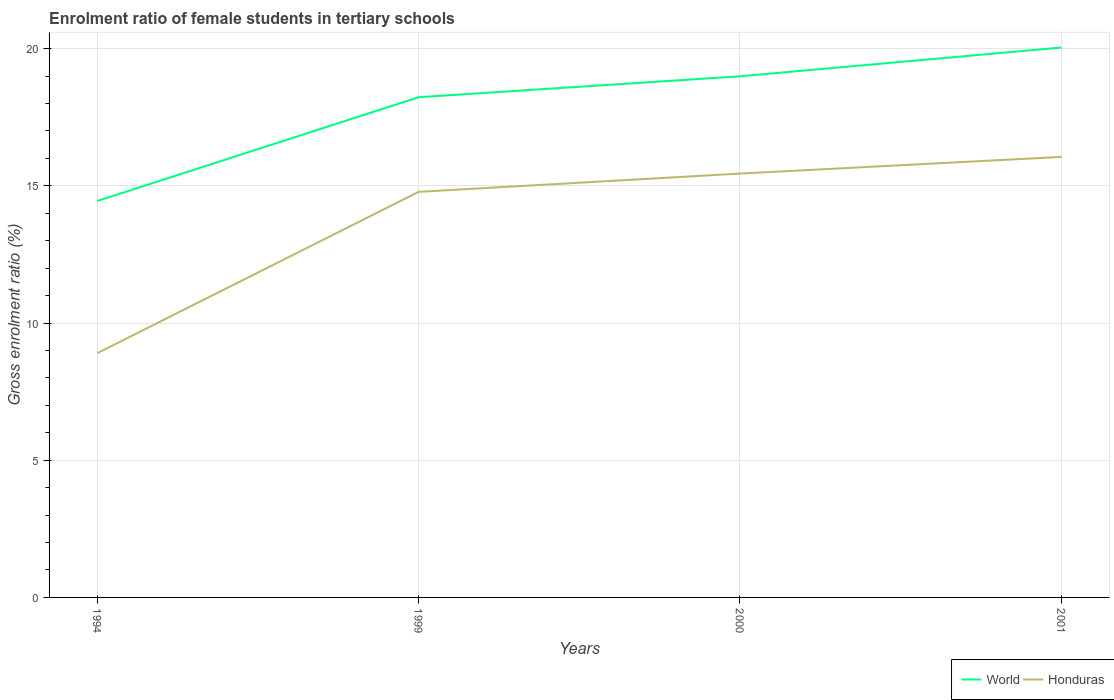How many different coloured lines are there?
Make the answer very short. 2. Does the line corresponding to Honduras intersect with the line corresponding to World?
Give a very brief answer. No. Across all years, what is the maximum enrolment ratio of female students in tertiary schools in Honduras?
Your response must be concise. 8.9. In which year was the enrolment ratio of female students in tertiary schools in World maximum?
Make the answer very short. 1994. What is the total enrolment ratio of female students in tertiary schools in World in the graph?
Give a very brief answer. -5.59. What is the difference between the highest and the second highest enrolment ratio of female students in tertiary schools in World?
Your answer should be very brief. 5.59. What is the difference between the highest and the lowest enrolment ratio of female students in tertiary schools in Honduras?
Offer a very short reply. 3. Is the enrolment ratio of female students in tertiary schools in World strictly greater than the enrolment ratio of female students in tertiary schools in Honduras over the years?
Make the answer very short. No. What is the difference between two consecutive major ticks on the Y-axis?
Your answer should be compact. 5. Does the graph contain grids?
Keep it short and to the point. Yes. How many legend labels are there?
Your answer should be very brief. 2. What is the title of the graph?
Your response must be concise. Enrolment ratio of female students in tertiary schools. What is the label or title of the X-axis?
Your response must be concise. Years. What is the label or title of the Y-axis?
Keep it short and to the point. Gross enrolment ratio (%). What is the Gross enrolment ratio (%) in World in 1994?
Ensure brevity in your answer.  14.45. What is the Gross enrolment ratio (%) in Honduras in 1994?
Your answer should be compact. 8.9. What is the Gross enrolment ratio (%) in World in 1999?
Offer a terse response. 18.23. What is the Gross enrolment ratio (%) in Honduras in 1999?
Your answer should be compact. 14.78. What is the Gross enrolment ratio (%) of World in 2000?
Your response must be concise. 18.99. What is the Gross enrolment ratio (%) of Honduras in 2000?
Give a very brief answer. 15.45. What is the Gross enrolment ratio (%) of World in 2001?
Your answer should be very brief. 20.04. What is the Gross enrolment ratio (%) of Honduras in 2001?
Keep it short and to the point. 16.06. Across all years, what is the maximum Gross enrolment ratio (%) in World?
Offer a very short reply. 20.04. Across all years, what is the maximum Gross enrolment ratio (%) in Honduras?
Provide a succinct answer. 16.06. Across all years, what is the minimum Gross enrolment ratio (%) in World?
Give a very brief answer. 14.45. Across all years, what is the minimum Gross enrolment ratio (%) in Honduras?
Your answer should be compact. 8.9. What is the total Gross enrolment ratio (%) in World in the graph?
Your answer should be compact. 71.71. What is the total Gross enrolment ratio (%) of Honduras in the graph?
Your answer should be very brief. 55.19. What is the difference between the Gross enrolment ratio (%) of World in 1994 and that in 1999?
Keep it short and to the point. -3.78. What is the difference between the Gross enrolment ratio (%) of Honduras in 1994 and that in 1999?
Your response must be concise. -5.88. What is the difference between the Gross enrolment ratio (%) of World in 1994 and that in 2000?
Provide a succinct answer. -4.54. What is the difference between the Gross enrolment ratio (%) of Honduras in 1994 and that in 2000?
Offer a very short reply. -6.54. What is the difference between the Gross enrolment ratio (%) in World in 1994 and that in 2001?
Provide a succinct answer. -5.59. What is the difference between the Gross enrolment ratio (%) in Honduras in 1994 and that in 2001?
Offer a very short reply. -7.15. What is the difference between the Gross enrolment ratio (%) in World in 1999 and that in 2000?
Offer a terse response. -0.76. What is the difference between the Gross enrolment ratio (%) in Honduras in 1999 and that in 2000?
Keep it short and to the point. -0.67. What is the difference between the Gross enrolment ratio (%) of World in 1999 and that in 2001?
Provide a short and direct response. -1.81. What is the difference between the Gross enrolment ratio (%) of Honduras in 1999 and that in 2001?
Ensure brevity in your answer.  -1.27. What is the difference between the Gross enrolment ratio (%) in World in 2000 and that in 2001?
Your answer should be compact. -1.05. What is the difference between the Gross enrolment ratio (%) in Honduras in 2000 and that in 2001?
Make the answer very short. -0.61. What is the difference between the Gross enrolment ratio (%) in World in 1994 and the Gross enrolment ratio (%) in Honduras in 1999?
Provide a succinct answer. -0.33. What is the difference between the Gross enrolment ratio (%) in World in 1994 and the Gross enrolment ratio (%) in Honduras in 2000?
Your answer should be compact. -1. What is the difference between the Gross enrolment ratio (%) in World in 1994 and the Gross enrolment ratio (%) in Honduras in 2001?
Offer a terse response. -1.61. What is the difference between the Gross enrolment ratio (%) in World in 1999 and the Gross enrolment ratio (%) in Honduras in 2000?
Your answer should be very brief. 2.78. What is the difference between the Gross enrolment ratio (%) in World in 1999 and the Gross enrolment ratio (%) in Honduras in 2001?
Give a very brief answer. 2.17. What is the difference between the Gross enrolment ratio (%) of World in 2000 and the Gross enrolment ratio (%) of Honduras in 2001?
Your response must be concise. 2.94. What is the average Gross enrolment ratio (%) of World per year?
Keep it short and to the point. 17.93. What is the average Gross enrolment ratio (%) of Honduras per year?
Offer a terse response. 13.8. In the year 1994, what is the difference between the Gross enrolment ratio (%) in World and Gross enrolment ratio (%) in Honduras?
Provide a succinct answer. 5.55. In the year 1999, what is the difference between the Gross enrolment ratio (%) in World and Gross enrolment ratio (%) in Honduras?
Provide a short and direct response. 3.45. In the year 2000, what is the difference between the Gross enrolment ratio (%) of World and Gross enrolment ratio (%) of Honduras?
Provide a short and direct response. 3.55. In the year 2001, what is the difference between the Gross enrolment ratio (%) in World and Gross enrolment ratio (%) in Honduras?
Keep it short and to the point. 3.99. What is the ratio of the Gross enrolment ratio (%) in World in 1994 to that in 1999?
Make the answer very short. 0.79. What is the ratio of the Gross enrolment ratio (%) in Honduras in 1994 to that in 1999?
Keep it short and to the point. 0.6. What is the ratio of the Gross enrolment ratio (%) of World in 1994 to that in 2000?
Provide a succinct answer. 0.76. What is the ratio of the Gross enrolment ratio (%) in Honduras in 1994 to that in 2000?
Your answer should be compact. 0.58. What is the ratio of the Gross enrolment ratio (%) of World in 1994 to that in 2001?
Keep it short and to the point. 0.72. What is the ratio of the Gross enrolment ratio (%) in Honduras in 1994 to that in 2001?
Offer a very short reply. 0.55. What is the ratio of the Gross enrolment ratio (%) in World in 1999 to that in 2000?
Your answer should be compact. 0.96. What is the ratio of the Gross enrolment ratio (%) of Honduras in 1999 to that in 2000?
Give a very brief answer. 0.96. What is the ratio of the Gross enrolment ratio (%) in World in 1999 to that in 2001?
Make the answer very short. 0.91. What is the ratio of the Gross enrolment ratio (%) of Honduras in 1999 to that in 2001?
Offer a terse response. 0.92. What is the ratio of the Gross enrolment ratio (%) in World in 2000 to that in 2001?
Provide a short and direct response. 0.95. What is the ratio of the Gross enrolment ratio (%) of Honduras in 2000 to that in 2001?
Your answer should be compact. 0.96. What is the difference between the highest and the second highest Gross enrolment ratio (%) in World?
Make the answer very short. 1.05. What is the difference between the highest and the second highest Gross enrolment ratio (%) of Honduras?
Provide a short and direct response. 0.61. What is the difference between the highest and the lowest Gross enrolment ratio (%) of World?
Offer a very short reply. 5.59. What is the difference between the highest and the lowest Gross enrolment ratio (%) in Honduras?
Your answer should be compact. 7.15. 